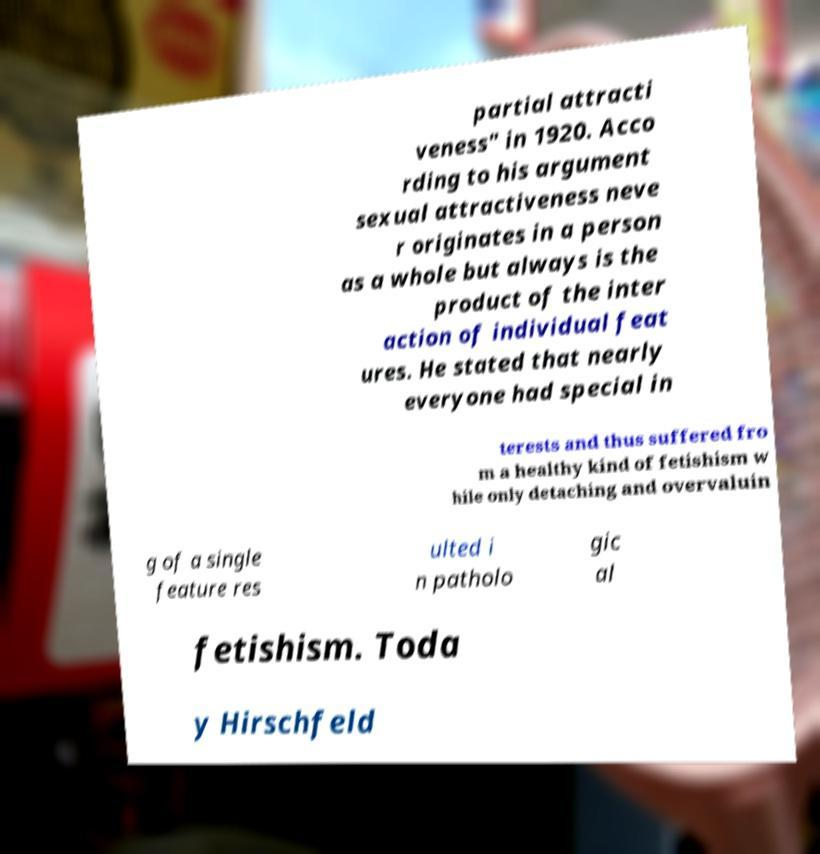Can you read and provide the text displayed in the image?This photo seems to have some interesting text. Can you extract and type it out for me? partial attracti veness" in 1920. Acco rding to his argument sexual attractiveness neve r originates in a person as a whole but always is the product of the inter action of individual feat ures. He stated that nearly everyone had special in terests and thus suffered fro m a healthy kind of fetishism w hile only detaching and overvaluin g of a single feature res ulted i n patholo gic al fetishism. Toda y Hirschfeld 